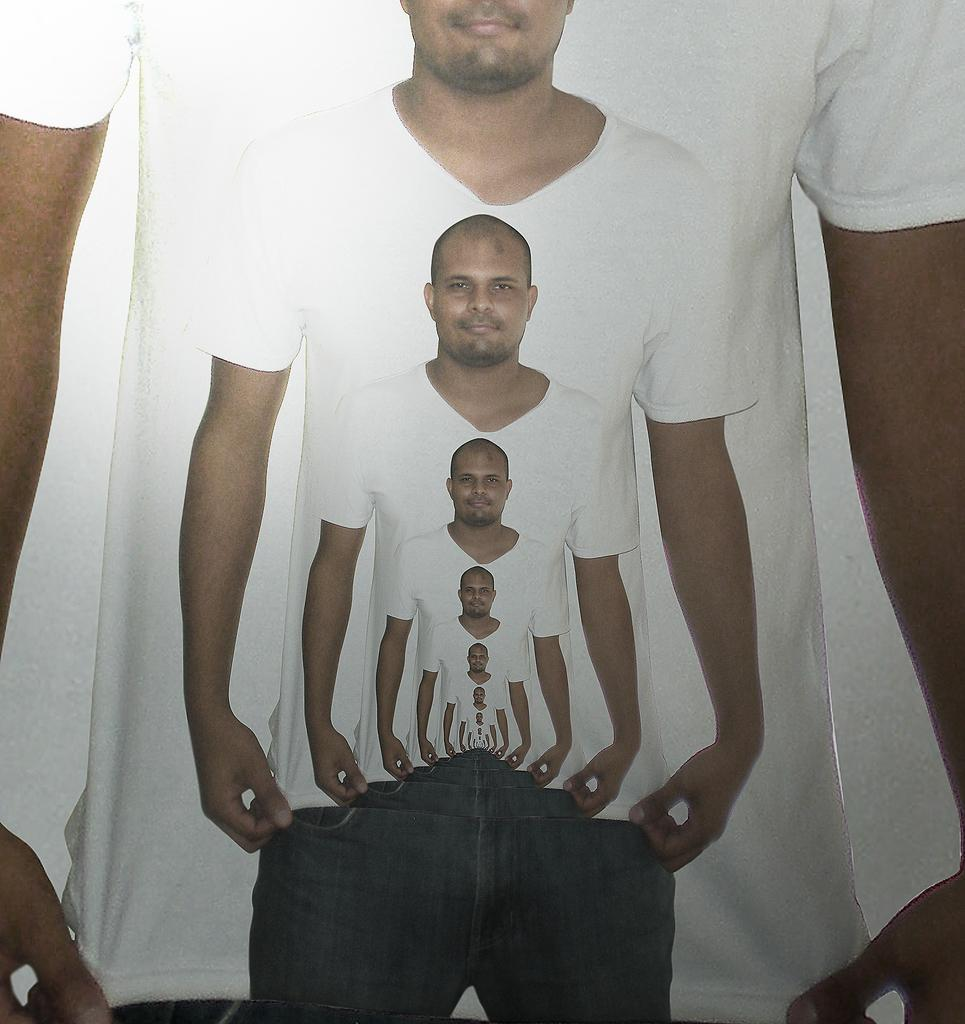What is the main subject of the image? The main subject of the image is a person. Has the image been altered in any way? Yes, the image is an edited image of a person. What type of bird can be seen flying in the image? There is no bird present in the image; it is an edited image of a person. What kind of meat is being cooked in the image? There is no meat or cooking activity depicted in the image; it is an edited image of a person. 